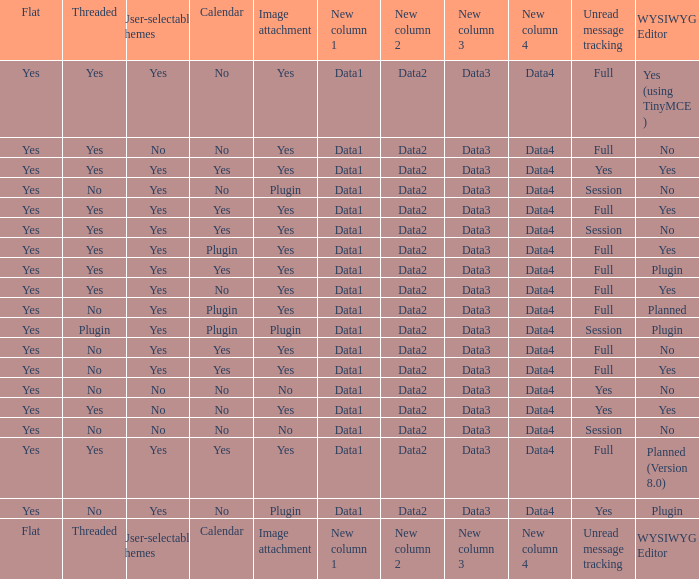Which Calendar has WYSIWYG Editor of yes and an Unread message tracking of yes? Yes, No. 